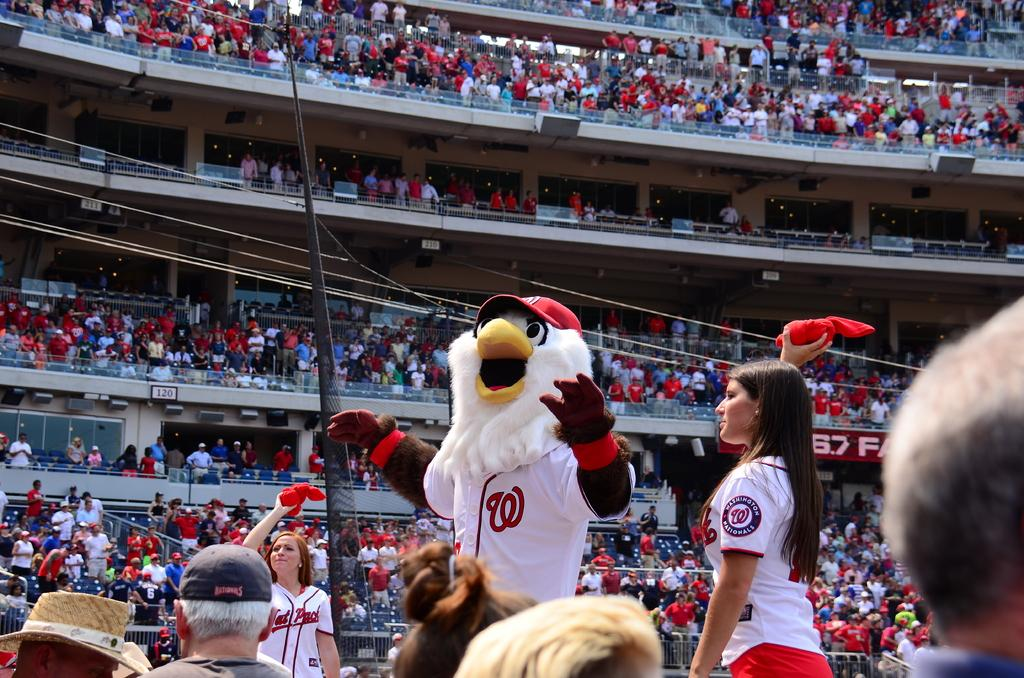<image>
Describe the image concisely. a bird mascot that has a W on his jersey 